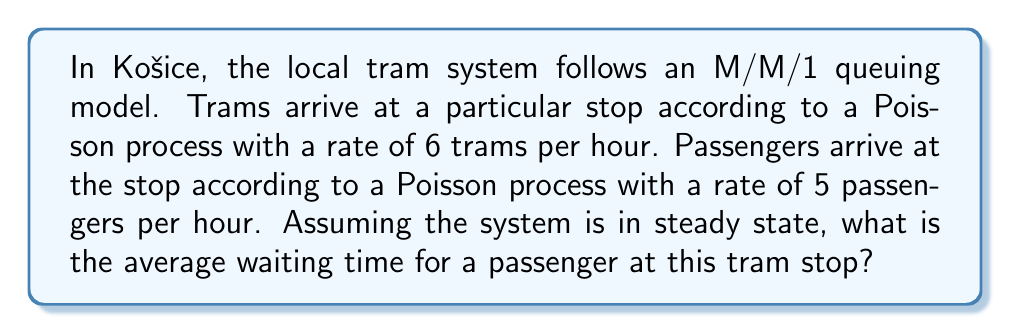Could you help me with this problem? Let's approach this step-by-step using queuing theory:

1) In an M/M/1 queue, the average waiting time (W) is given by the formula:

   $$W = \frac{1}{\mu - \lambda}$$

   where $\lambda$ is the arrival rate of customers (passengers in this case) and $\mu$ is the service rate.

2) We're given:
   - Tram arrival rate (service rate) $\mu = 6$ per hour
   - Passenger arrival rate $\lambda = 5$ per hour

3) Substituting these values into the formula:

   $$W = \frac{1}{6 - 5} = \frac{1}{1} = 1$$

4) This gives us the average waiting time in hours.

5) To convert to minutes, we multiply by 60:

   $$W_{minutes} = 1 \times 60 = 60$$

Therefore, the average waiting time for a passenger at this tram stop is 60 minutes or 1 hour.

Note: This model assumes that the system is in steady state and that the arrival and service processes are truly Poisson. In reality, tram schedules and passenger arrivals might follow more complex patterns, especially during peak hours.
Answer: 60 minutes 